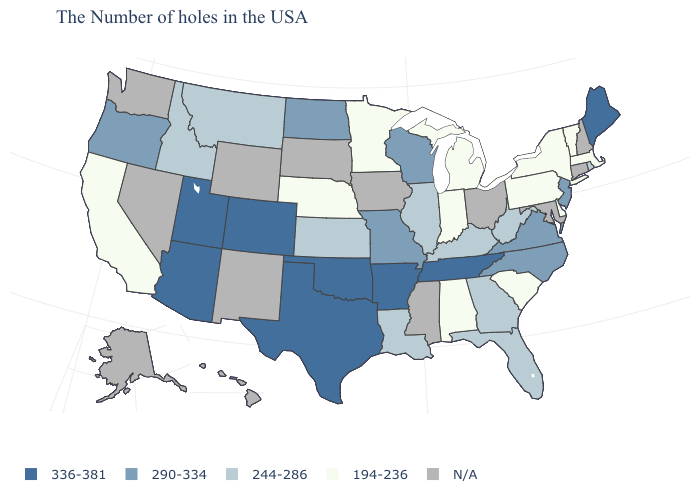Does Alabama have the lowest value in the South?
Write a very short answer. Yes. Name the states that have a value in the range N/A?
Keep it brief. New Hampshire, Connecticut, Maryland, Ohio, Mississippi, Iowa, South Dakota, Wyoming, New Mexico, Nevada, Washington, Alaska, Hawaii. Among the states that border North Dakota , does Montana have the highest value?
Write a very short answer. Yes. What is the value of Georgia?
Concise answer only. 244-286. Does Florida have the lowest value in the USA?
Answer briefly. No. Among the states that border Colorado , does Nebraska have the lowest value?
Short answer required. Yes. Does Indiana have the highest value in the MidWest?
Concise answer only. No. What is the value of New Hampshire?
Write a very short answer. N/A. What is the value of Indiana?
Keep it brief. 194-236. Does Utah have the lowest value in the West?
Answer briefly. No. Name the states that have a value in the range 290-334?
Be succinct. New Jersey, Virginia, North Carolina, Wisconsin, Missouri, North Dakota, Oregon. Among the states that border Montana , does Idaho have the lowest value?
Short answer required. Yes. What is the value of Maryland?
Give a very brief answer. N/A. What is the lowest value in the West?
Short answer required. 194-236. 